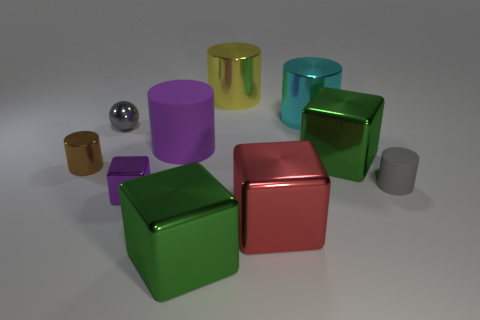Subtract all cyan cylinders. How many cylinders are left? 4 Subtract all brown cylinders. How many cylinders are left? 4 Subtract all red cylinders. Subtract all purple cubes. How many cylinders are left? 5 Subtract all balls. How many objects are left? 9 Subtract 0 brown cubes. How many objects are left? 10 Subtract all cyan rubber things. Subtract all metallic cylinders. How many objects are left? 7 Add 3 large things. How many large things are left? 9 Add 6 tiny brown objects. How many tiny brown objects exist? 7 